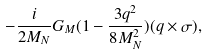<formula> <loc_0><loc_0><loc_500><loc_500>- \frac { i } { 2 M _ { N } } G _ { M } ( 1 - \frac { 3 { q } ^ { 2 } } { 8 M _ { N } ^ { 2 } } ) ( { q } \times \sigma ) ,</formula> 